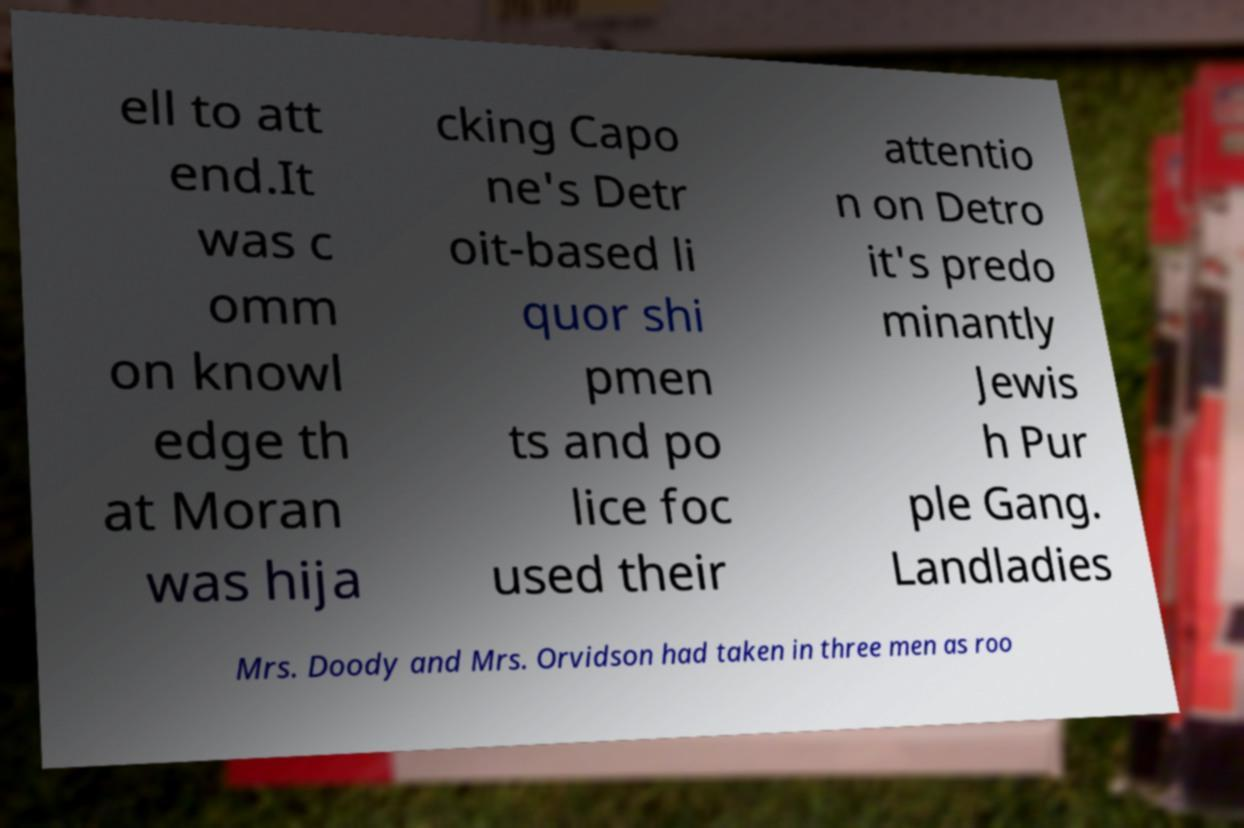I need the written content from this picture converted into text. Can you do that? ell to att end.It was c omm on knowl edge th at Moran was hija cking Capo ne's Detr oit-based li quor shi pmen ts and po lice foc used their attentio n on Detro it's predo minantly Jewis h Pur ple Gang. Landladies Mrs. Doody and Mrs. Orvidson had taken in three men as roo 